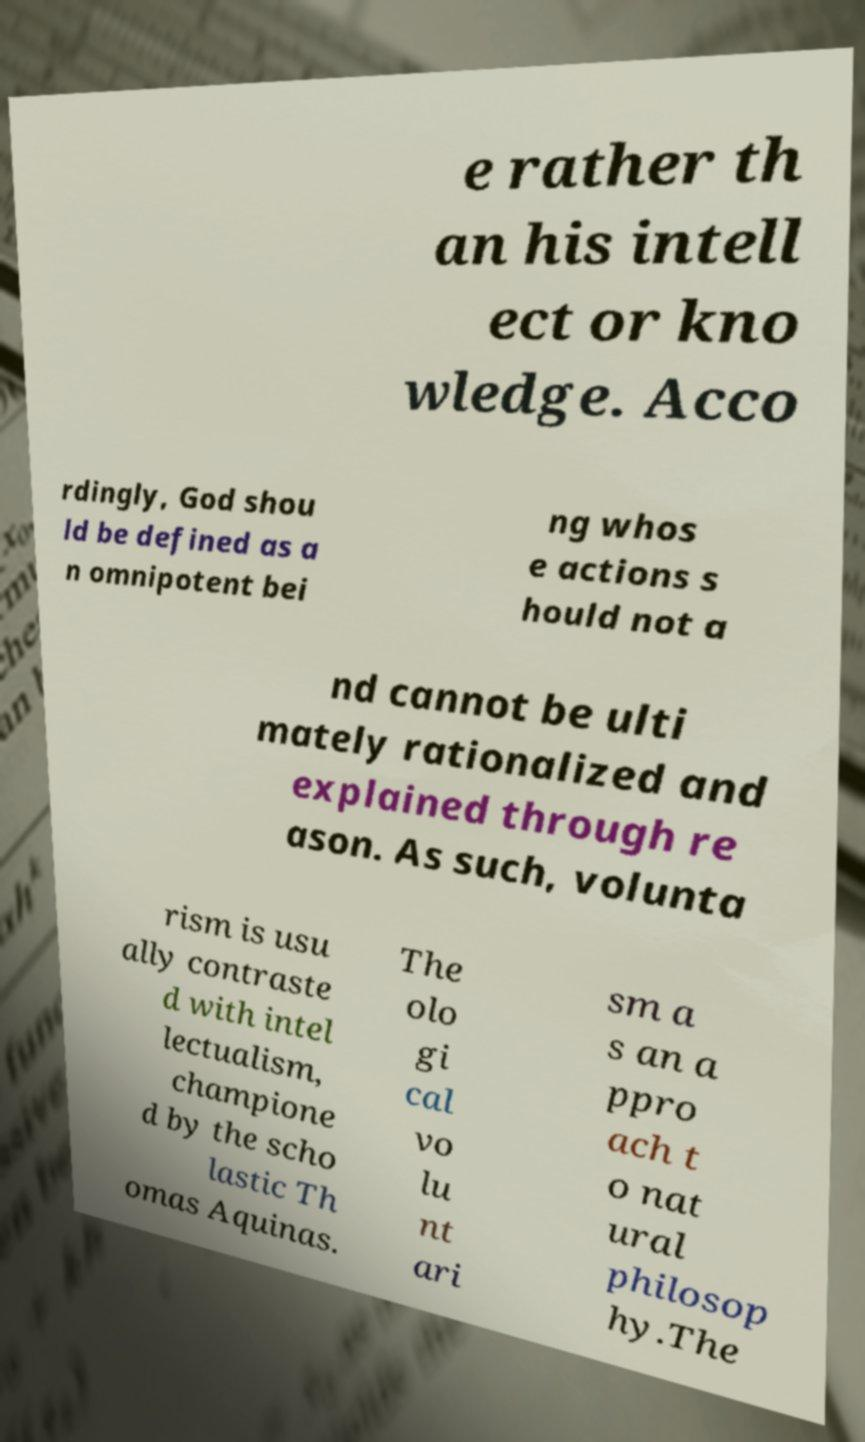Please identify and transcribe the text found in this image. e rather th an his intell ect or kno wledge. Acco rdingly, God shou ld be defined as a n omnipotent bei ng whos e actions s hould not a nd cannot be ulti mately rationalized and explained through re ason. As such, volunta rism is usu ally contraste d with intel lectualism, champione d by the scho lastic Th omas Aquinas. The olo gi cal vo lu nt ari sm a s an a ppro ach t o nat ural philosop hy.The 